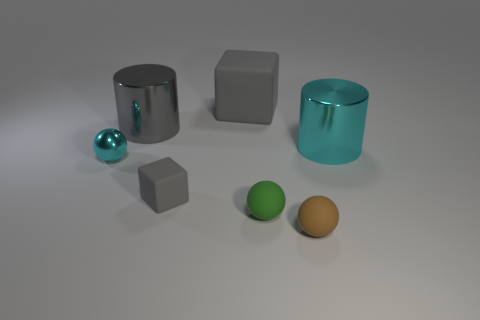Add 1 tiny things. How many objects exist? 8 Subtract all blocks. How many objects are left? 5 Subtract all small purple metallic cubes. Subtract all tiny green rubber balls. How many objects are left? 6 Add 3 small cubes. How many small cubes are left? 4 Add 5 gray cylinders. How many gray cylinders exist? 6 Subtract 0 green blocks. How many objects are left? 7 